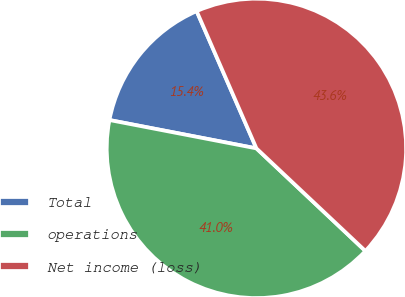Convert chart. <chart><loc_0><loc_0><loc_500><loc_500><pie_chart><fcel>Total<fcel>operations<fcel>Net income (loss)<nl><fcel>15.43%<fcel>41.01%<fcel>43.56%<nl></chart> 